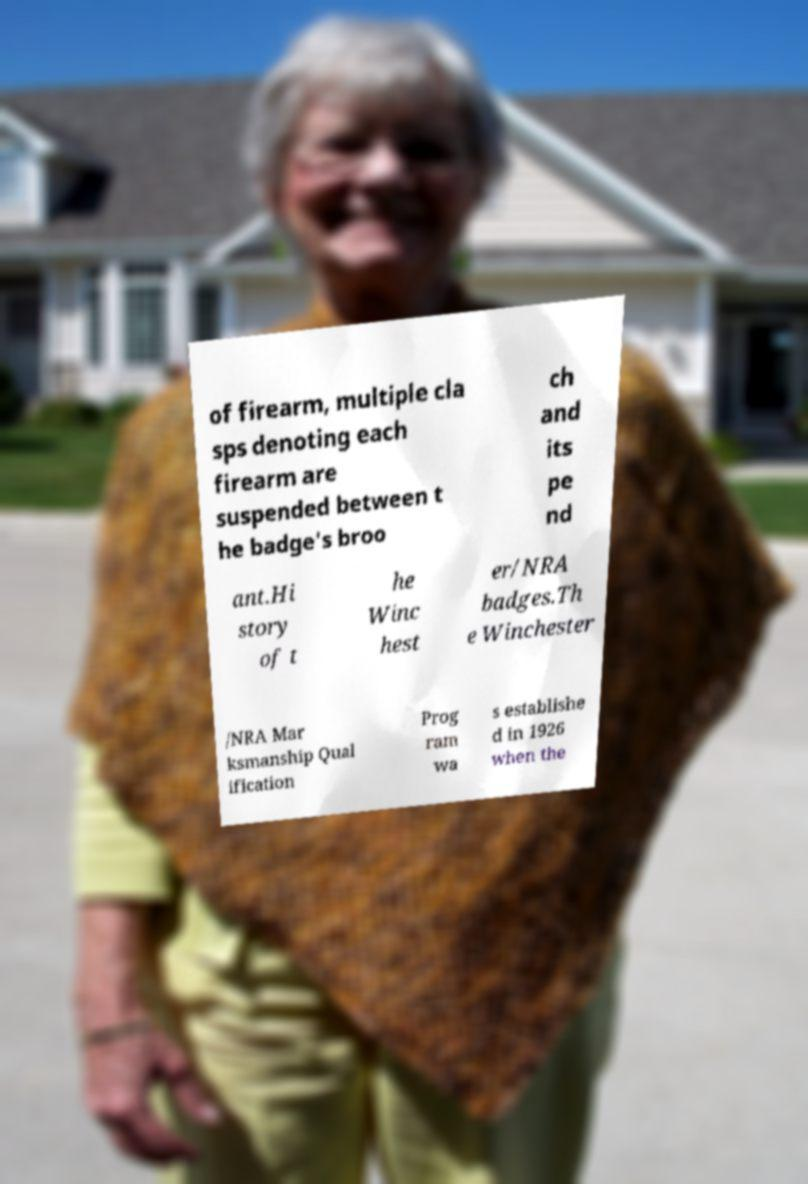For documentation purposes, I need the text within this image transcribed. Could you provide that? of firearm, multiple cla sps denoting each firearm are suspended between t he badge's broo ch and its pe nd ant.Hi story of t he Winc hest er/NRA badges.Th e Winchester /NRA Mar ksmanship Qual ification Prog ram wa s establishe d in 1926 when the 